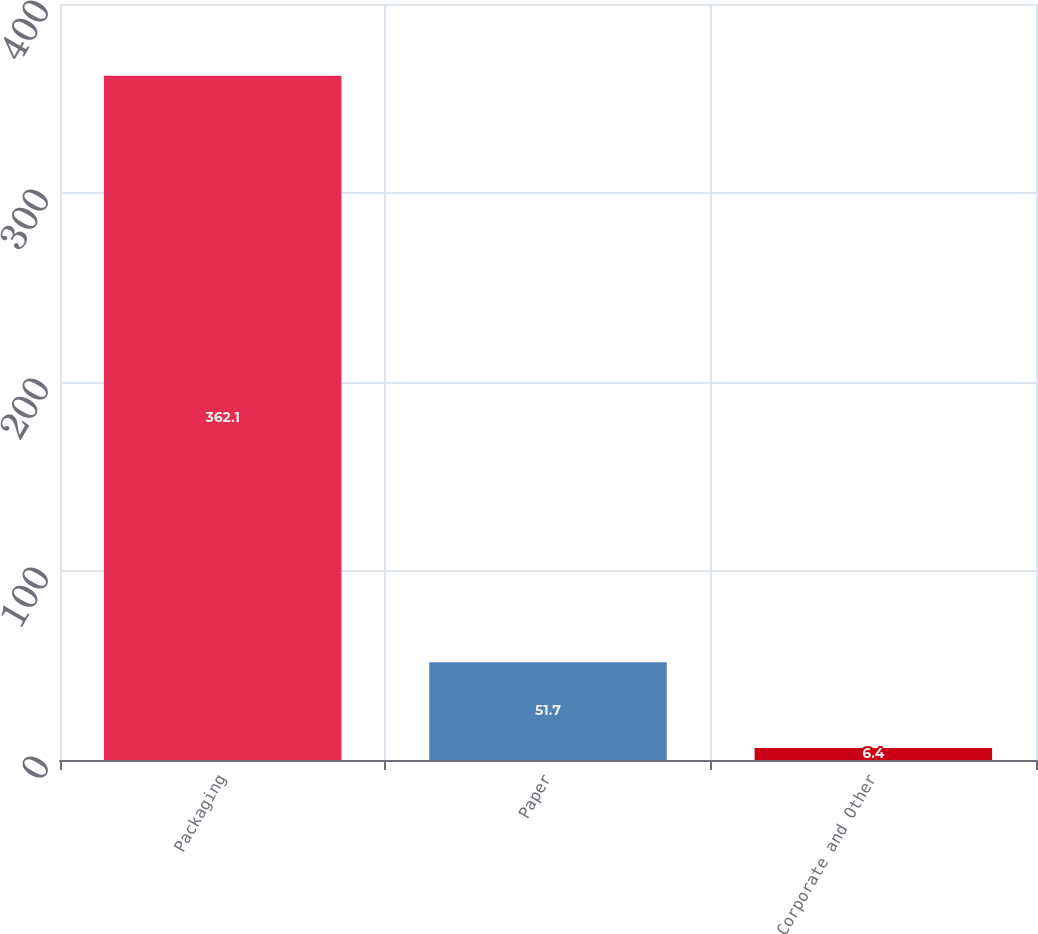Convert chart. <chart><loc_0><loc_0><loc_500><loc_500><bar_chart><fcel>Packaging<fcel>Paper<fcel>Corporate and Other<nl><fcel>362.1<fcel>51.7<fcel>6.4<nl></chart> 